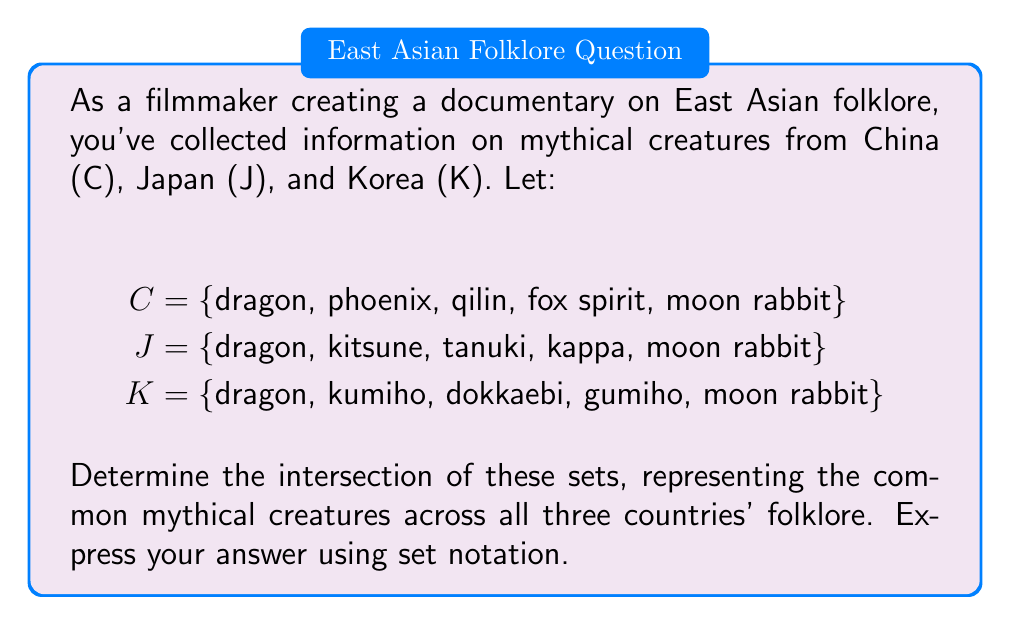Provide a solution to this math problem. To solve this problem, we need to find the elements that are present in all three sets. Let's follow these steps:

1. Identify the elements in each set:
   C = {dragon, phoenix, qilin, fox spirit, moon rabbit}
   J = {dragon, kitsune, tanuki, kappa, moon rabbit}
   K = {dragon, kumiho, dokkaebi, gumiho, moon rabbit}

2. Look for elements that appear in all three sets:
   - "dragon" appears in C, J, and K
   - "moon rabbit" appears in C, J, and K
   - No other elements appear in all three sets

3. The intersection of these sets is denoted by $C \cap J \cap K$, which contains all elements that are present in all three sets simultaneously.

4. Therefore, the intersection of these sets is:
   $C \cap J \cap K = \{dragon, moon rabbit\}$

This result shows that the dragon and moon rabbit are common mythical creatures in the folklore of China, Japan, and Korea, making them significant elements for the documentary's cross-cultural analysis.
Answer: $C \cap J \cap K = \{dragon, moon rabbit\}$ 